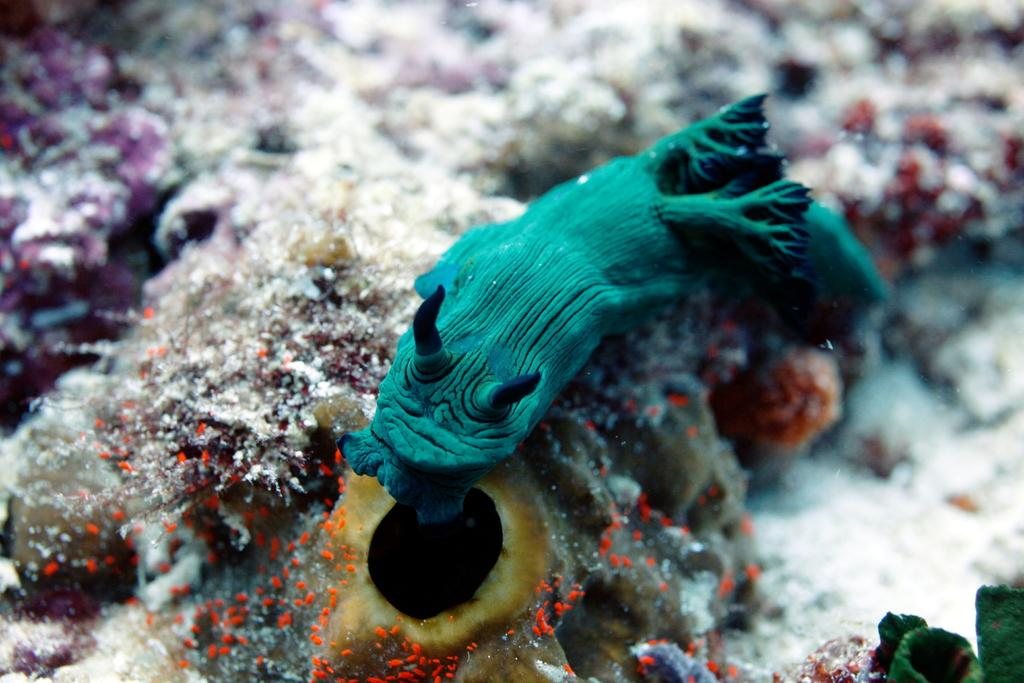Where was the image taken? The image was taken in an aquarium. What is the main subject of the image? There is a fish in the center of the image. What else can be seen at the bottom of the image? There are water plants at the bottom of the image. How many hairs can be seen on the fish in the image? Fish do not have hair, so there are no hairs visible on the fish in the image. 